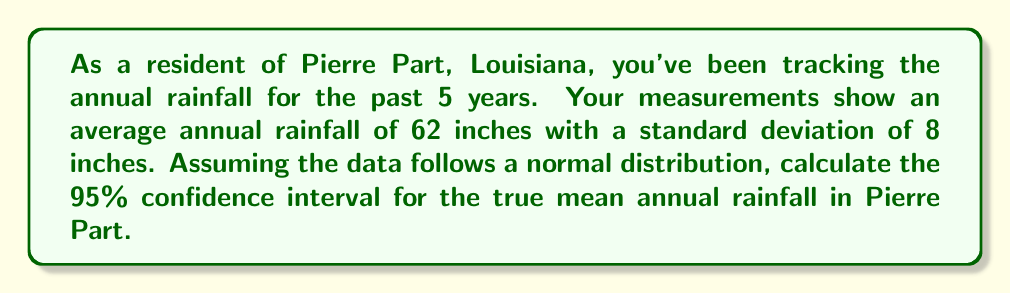Teach me how to tackle this problem. Let's calculate the confidence interval step by step:

1) We're given:
   - Sample mean ($\bar{x}$) = 62 inches
   - Sample standard deviation (s) = 8 inches
   - Sample size (n) = 5 years
   - Confidence level = 95%

2) For a 95% confidence interval, we use a t-distribution with (n-1) = 4 degrees of freedom.
   The t-value for a 95% confidence interval with 4 degrees of freedom is 2.776.

3) The formula for the confidence interval is:

   $$\bar{x} \pm t_{\frac{\alpha}{2}, n-1} \cdot \frac{s}{\sqrt{n}}$$

4) Let's substitute our values:

   $$62 \pm 2.776 \cdot \frac{8}{\sqrt{5}}$$

5) Simplify:
   $$62 \pm 2.776 \cdot \frac{8}{2.236}$$
   $$62 \pm 2.776 \cdot 3.578$$
   $$62 \pm 9.93$$

6) Calculate the interval:
   Lower bound: 62 - 9.93 = 52.07
   Upper bound: 62 + 9.93 = 71.93

Therefore, we can be 95% confident that the true mean annual rainfall in Pierre Part is between 52.07 and 71.93 inches.
Answer: (52.07, 71.93) inches 